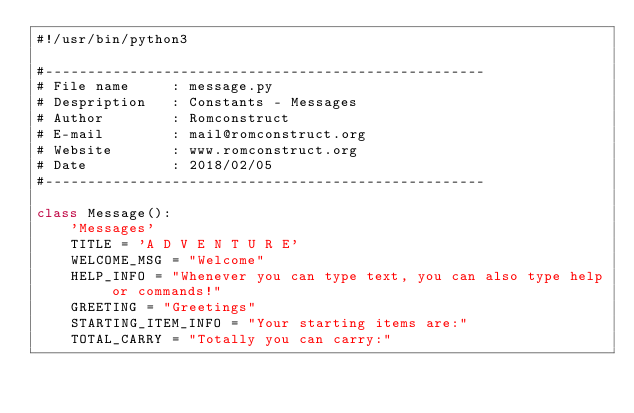Convert code to text. <code><loc_0><loc_0><loc_500><loc_500><_Python_>#!/usr/bin/python3

#----------------------------------------------------
# File name     : message.py
# Despription   : Constants - Messages
# Author        : Romconstruct
# E-mail        : mail@romconstruct.org
# Website       : www.romconstruct.org
# Date          : 2018/02/05
#----------------------------------------------------

class Message():
    'Messages'
    TITLE = 'A D V E N T U R E'
    WELCOME_MSG = "Welcome"
    HELP_INFO = "Whenever you can type text, you can also type help or commands!"
    GREETING = "Greetings"
    STARTING_ITEM_INFO = "Your starting items are:"
    TOTAL_CARRY = "Totally you can carry:"</code> 